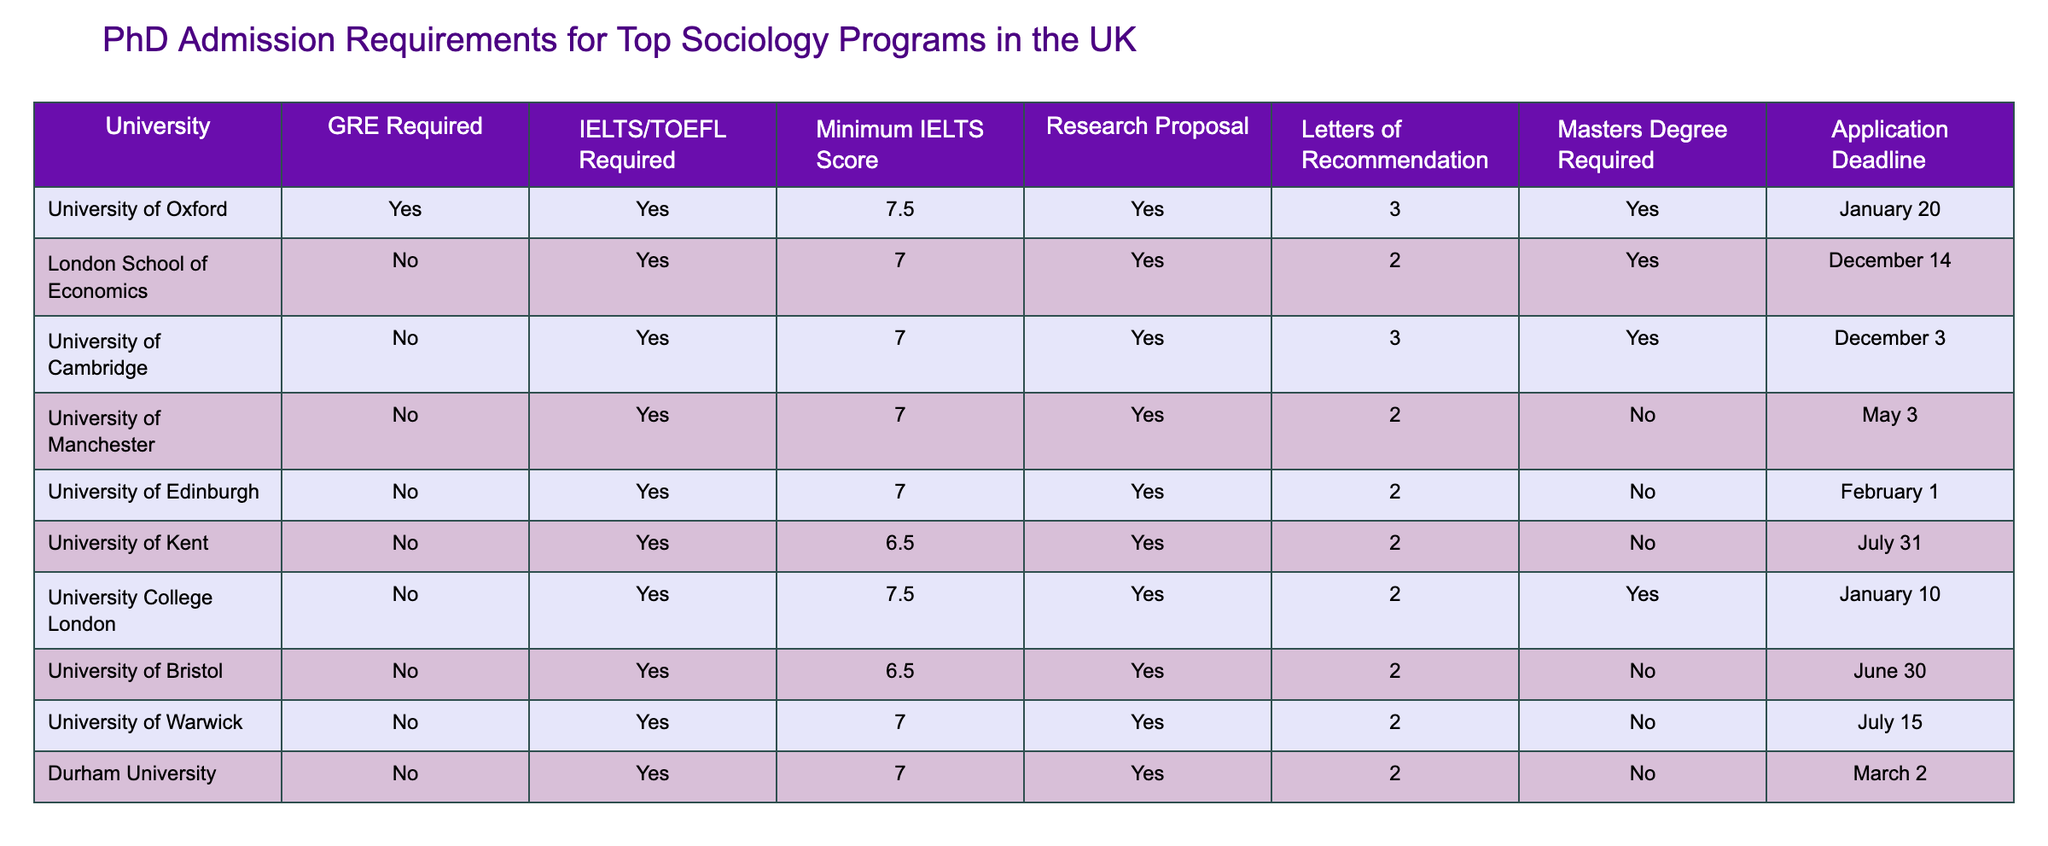What is the minimum IELTS score required for the University of Kent? The table specifies the minimum IELTS score for the University of Kent under the "Minimum IELTS Score" column. It shows a value of 6.5.
Answer: 6.5 How many letters of recommendation are needed for the University of Oxford? By referring to the "Letters of Recommendation" column for the University of Oxford, the table indicates that 3 letters are required.
Answer: 3 Is a master's degree required for the University of Manchester? Looking at the "Masters Degree Required" column for the University of Manchester, the table states "No," meaning a master’s degree is not required.
Answer: No Which university has the latest application deadline? The application deadlines for each university are listed. The latest deadline in the table is July 31 for the University of Kent.
Answer: University of Kent How many universities require GRE scores for PhD admission in Sociology? The table includes the "GRE Required" column where we need to count the "Yes" responses. The University of Oxford is the only university that requires GRE scores. Thus, there is 1 university.
Answer: 1 What is the average minimum IELTS score requirement among the listed universities? We can calculate the average by summing the minimum scores from each university (7.5 + 7.0 + 7.0 + 7.0 + 7.0 + 6.5 + 7.5 + 6.5 + 7.0 + 7.0) which equals 70.0. Then, dividing by the number of universities, 10, gives 70.0/10 = 7.0.
Answer: 7.0 Does the University of Cambridge require a research proposal? Referring to the "Research Proposal" column for the University of Cambridge, the table shows "Yes," indicating a research proposal is required.
Answer: Yes Which universities do not require a master's degree for admission? We look in the "Masters Degree Required" column for "No." The universities that do not require a master's degree are: University of Manchester, University of Edinburgh, University of Kent, University of Bristol, and University of Warwick, totaling 5 universities.
Answer: 5 